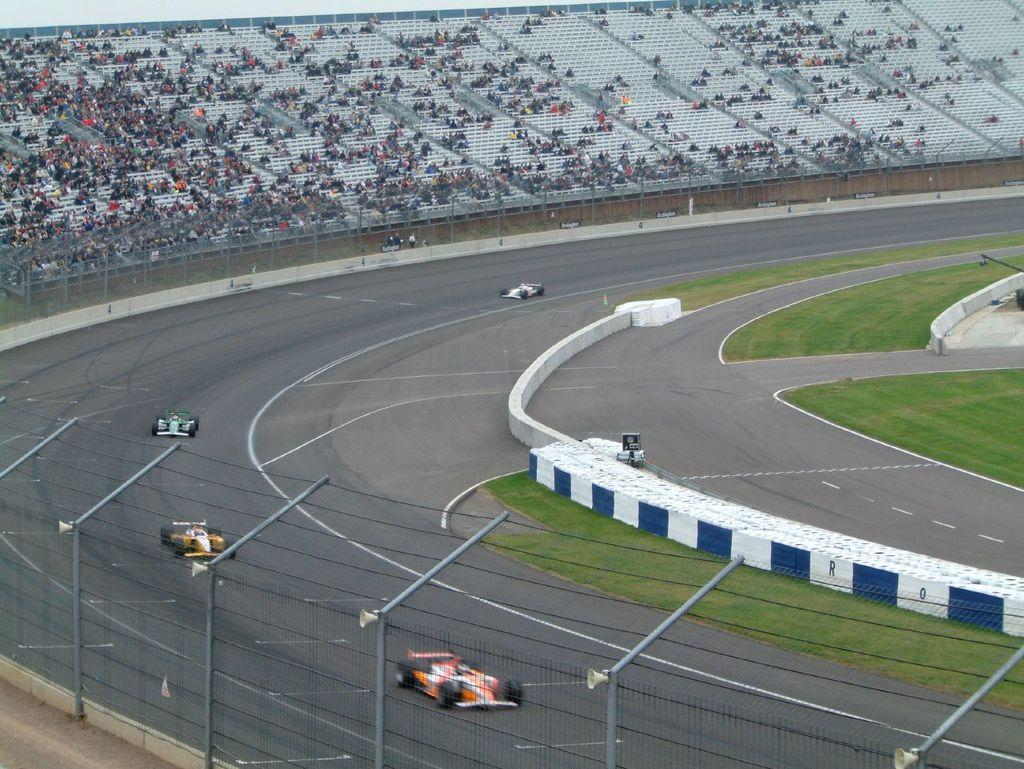What is the main feature of the image? There is a road in the image. What is happening on the road? There are cars moving on the road. What type of vegetation can be seen in the image? There is grass visible in the image. What type of barrier is present in the image? There is a fence in the image. What type of seating is present in the image? There are empty chairs and audience members sitting in the image. How many dimes are scattered on the road in the image? There are no dimes present in the image; it only features a road, cars, grass, a fence, chairs, and audience members. 